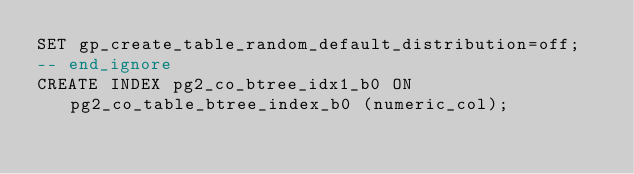Convert code to text. <code><loc_0><loc_0><loc_500><loc_500><_SQL_>SET gp_create_table_random_default_distribution=off;
-- end_ignore
CREATE INDEX pg2_co_btree_idx1_b0 ON pg2_co_table_btree_index_b0 (numeric_col);
</code> 